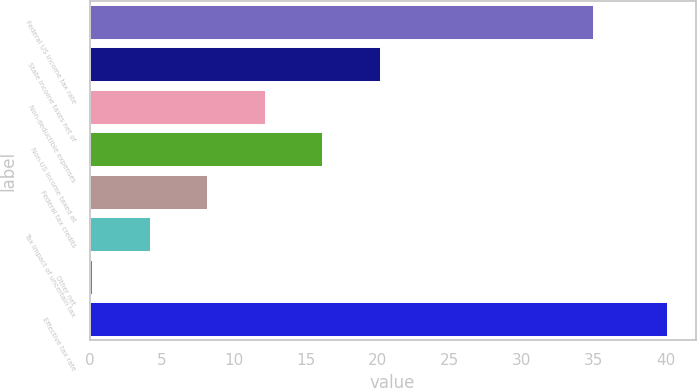Convert chart to OTSL. <chart><loc_0><loc_0><loc_500><loc_500><bar_chart><fcel>Federal US income tax rate<fcel>State income taxes net of<fcel>Non-deductible expenses<fcel>Non-US income taxed at<fcel>Federal tax credits<fcel>Tax impact of uncertain tax<fcel>Other net<fcel>Effective tax rate<nl><fcel>35<fcel>20.15<fcel>12.17<fcel>16.16<fcel>8.18<fcel>4.19<fcel>0.2<fcel>40.1<nl></chart> 